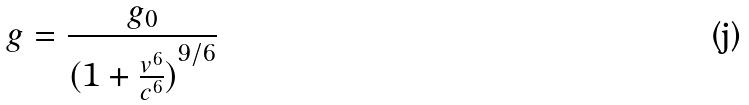Convert formula to latex. <formula><loc_0><loc_0><loc_500><loc_500>g = \frac { g _ { 0 } } { ( { 1 + \frac { v ^ { 6 } } { c ^ { 6 } } ) } ^ { 9 / 6 } }</formula> 